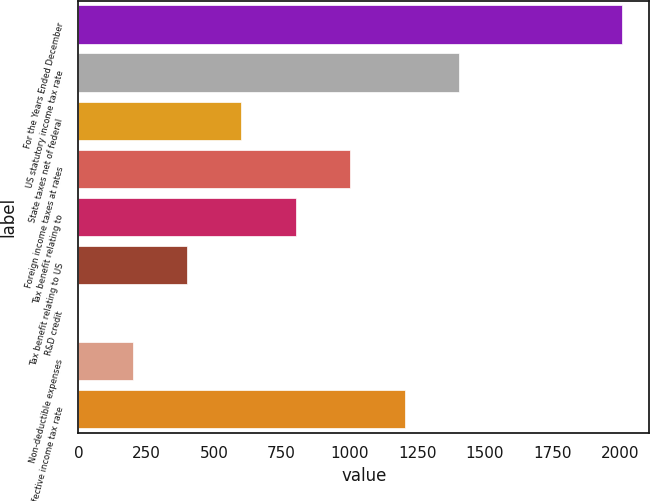Convert chart. <chart><loc_0><loc_0><loc_500><loc_500><bar_chart><fcel>For the Years Ended December<fcel>US statutory income tax rate<fcel>State taxes net of federal<fcel>Foreign income taxes at rates<fcel>Tax benefit relating to<fcel>Tax benefit relating to US<fcel>R&D credit<fcel>Non-deductible expenses<fcel>Effective income tax rate<nl><fcel>2006<fcel>1404.23<fcel>601.87<fcel>1003.05<fcel>802.46<fcel>401.28<fcel>0.1<fcel>200.69<fcel>1203.64<nl></chart> 